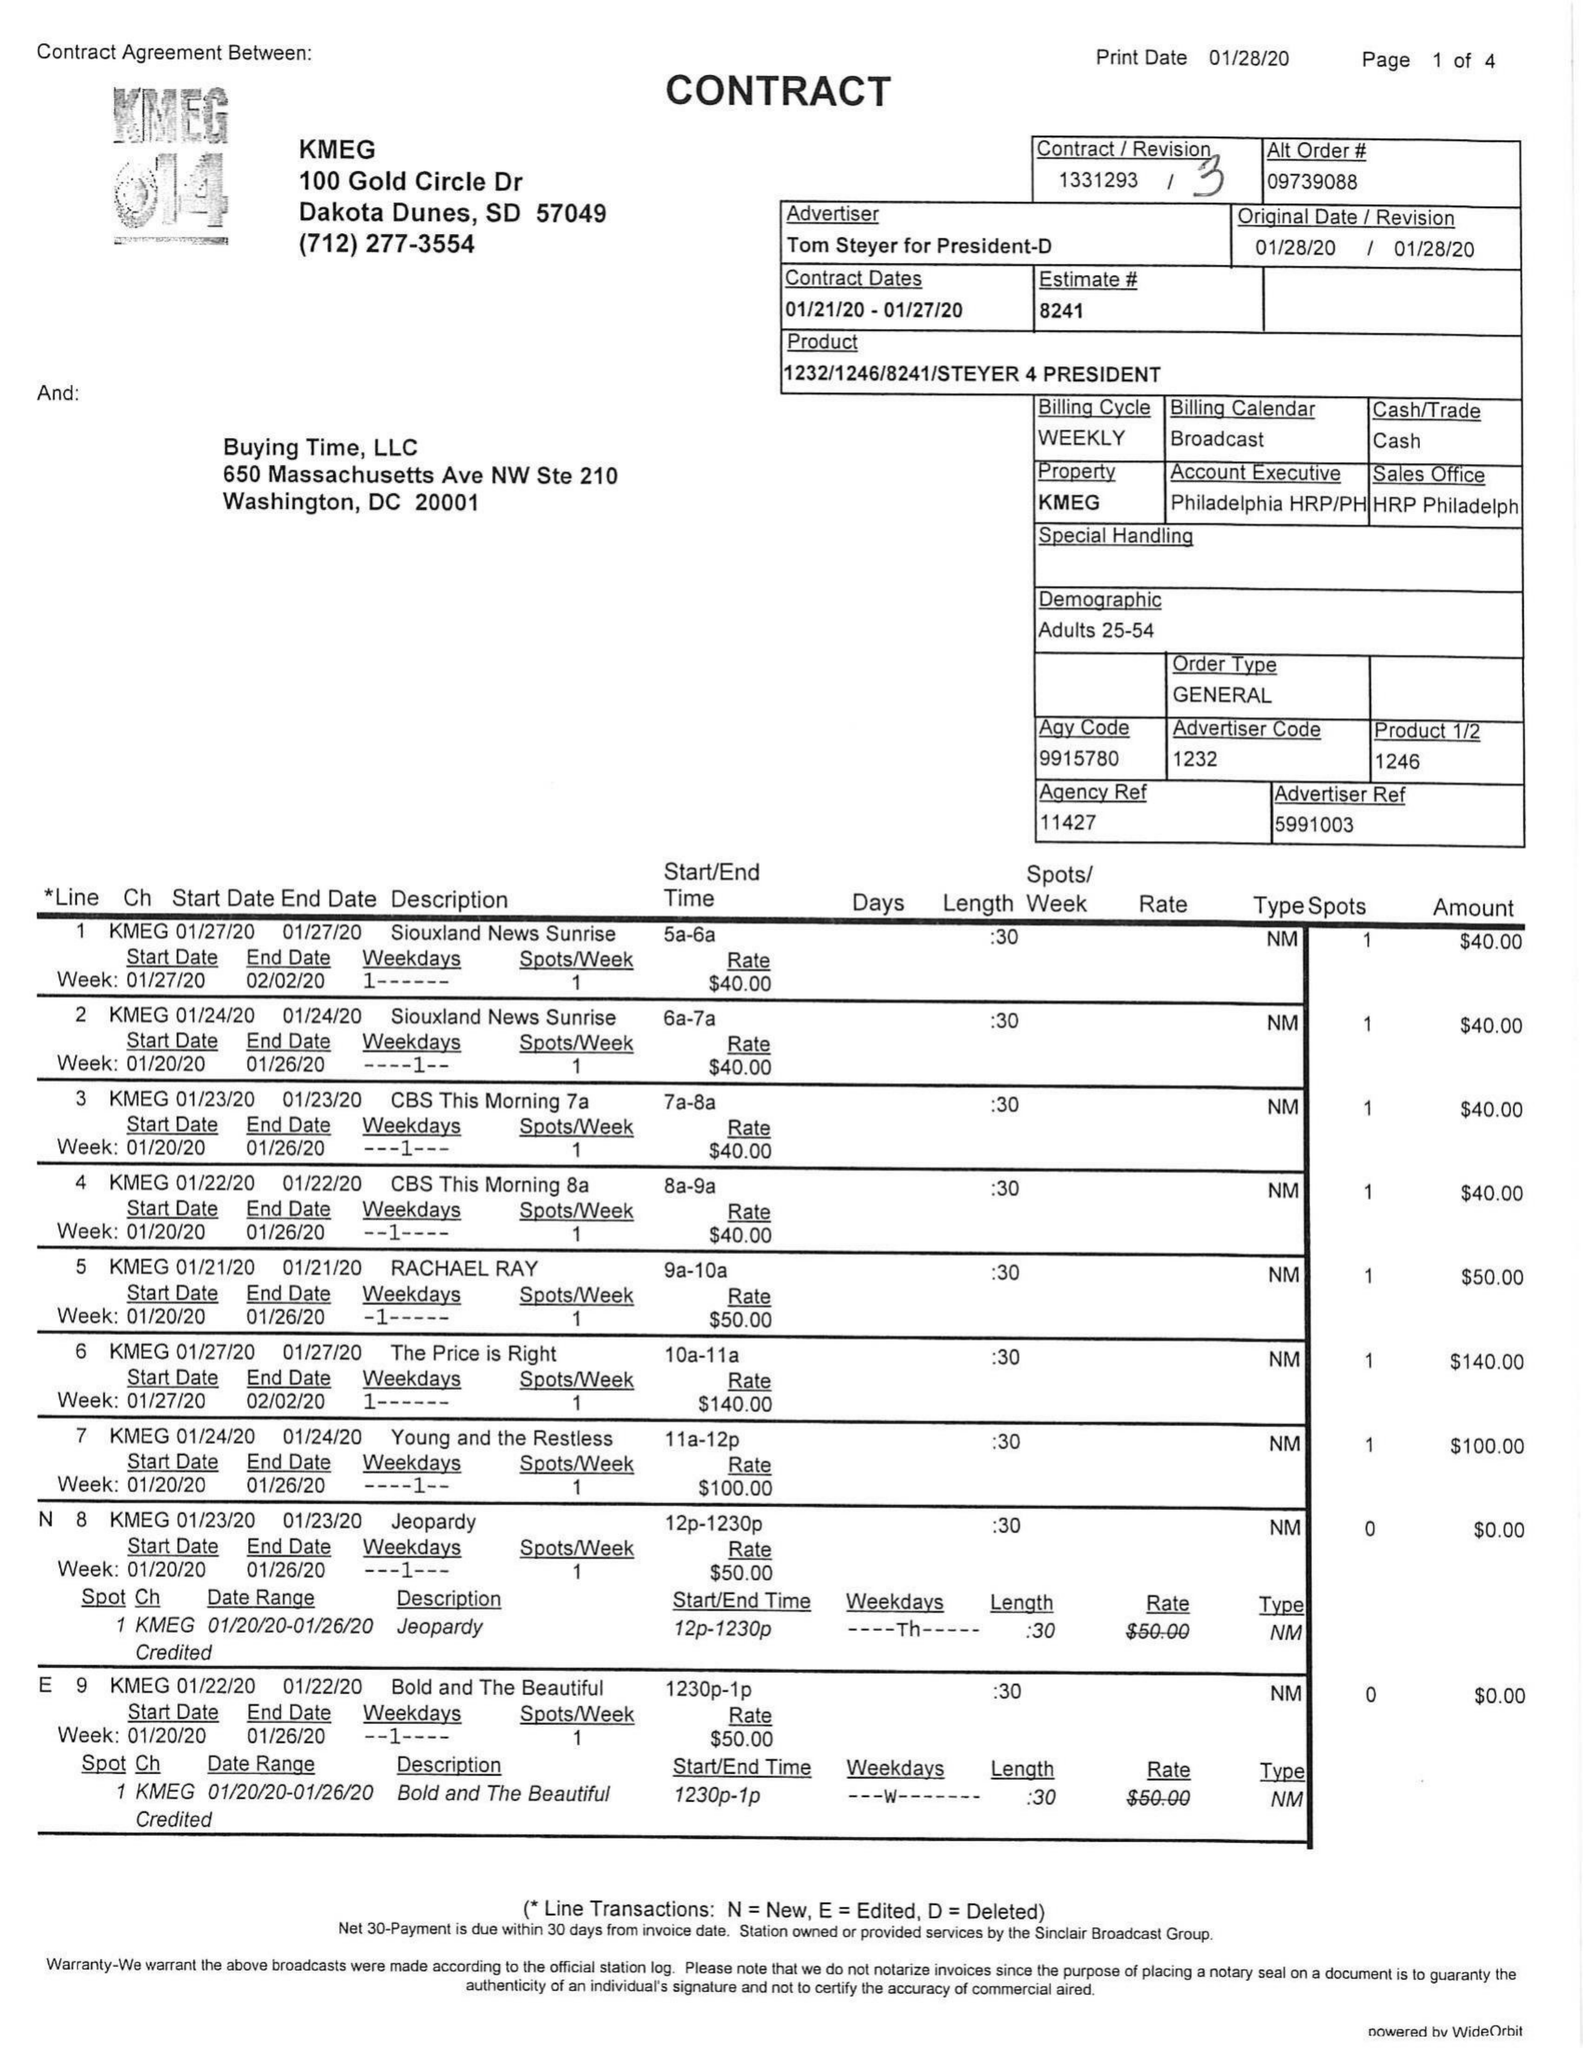What is the value for the flight_to?
Answer the question using a single word or phrase. 01/27/20 